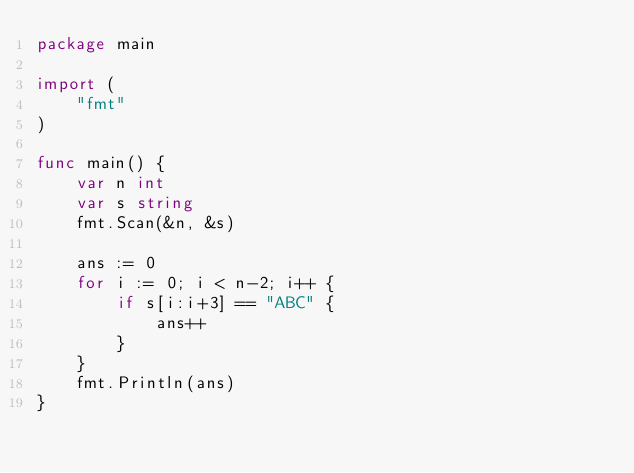Convert code to text. <code><loc_0><loc_0><loc_500><loc_500><_Go_>package main

import (
	"fmt"
)

func main() {
	var n int
	var s string
	fmt.Scan(&n, &s)

	ans := 0
	for i := 0; i < n-2; i++ {
		if s[i:i+3] == "ABC" {
			ans++
		}
	}
	fmt.Println(ans)
}
</code> 